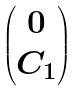Convert formula to latex. <formula><loc_0><loc_0><loc_500><loc_500>\begin{pmatrix} 0 \\ C _ { 1 } \end{pmatrix}</formula> 